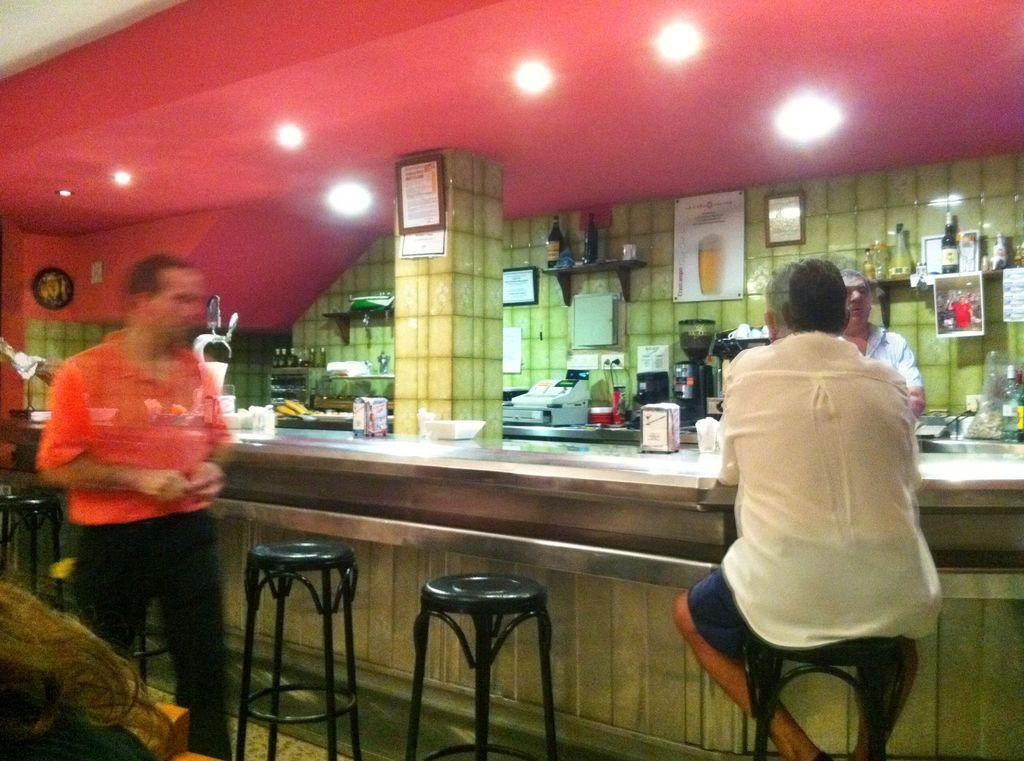What is the primary activity of the people in the image? The people in the image are standing. Can you describe the position of the man in the image? The man is sitting on a chair in the image. What type of glass is the man holding in the image? There is no glass present in the image; the man is sitting on a chair. 